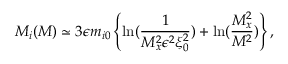Convert formula to latex. <formula><loc_0><loc_0><loc_500><loc_500>M _ { i } ( M ) \simeq 3 \epsilon m _ { i 0 } \left \{ \ln ( \frac { 1 } { M _ { x } ^ { 2 } \epsilon ^ { 2 } \xi _ { 0 } ^ { 2 } } ) + \ln ( \frac { M _ { x } ^ { 2 } } { M ^ { 2 } } ) \right \} ,</formula> 